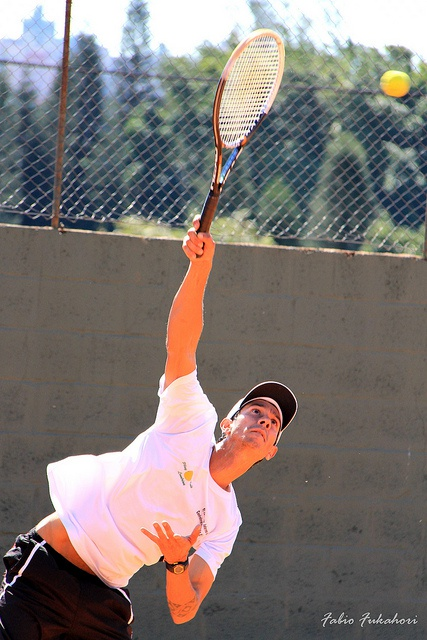Describe the objects in this image and their specific colors. I can see people in white, pink, black, salmon, and red tones, tennis racket in white, ivory, tan, and gray tones, sports ball in white, gold, khaki, and orange tones, and clock in white, red, and orange tones in this image. 